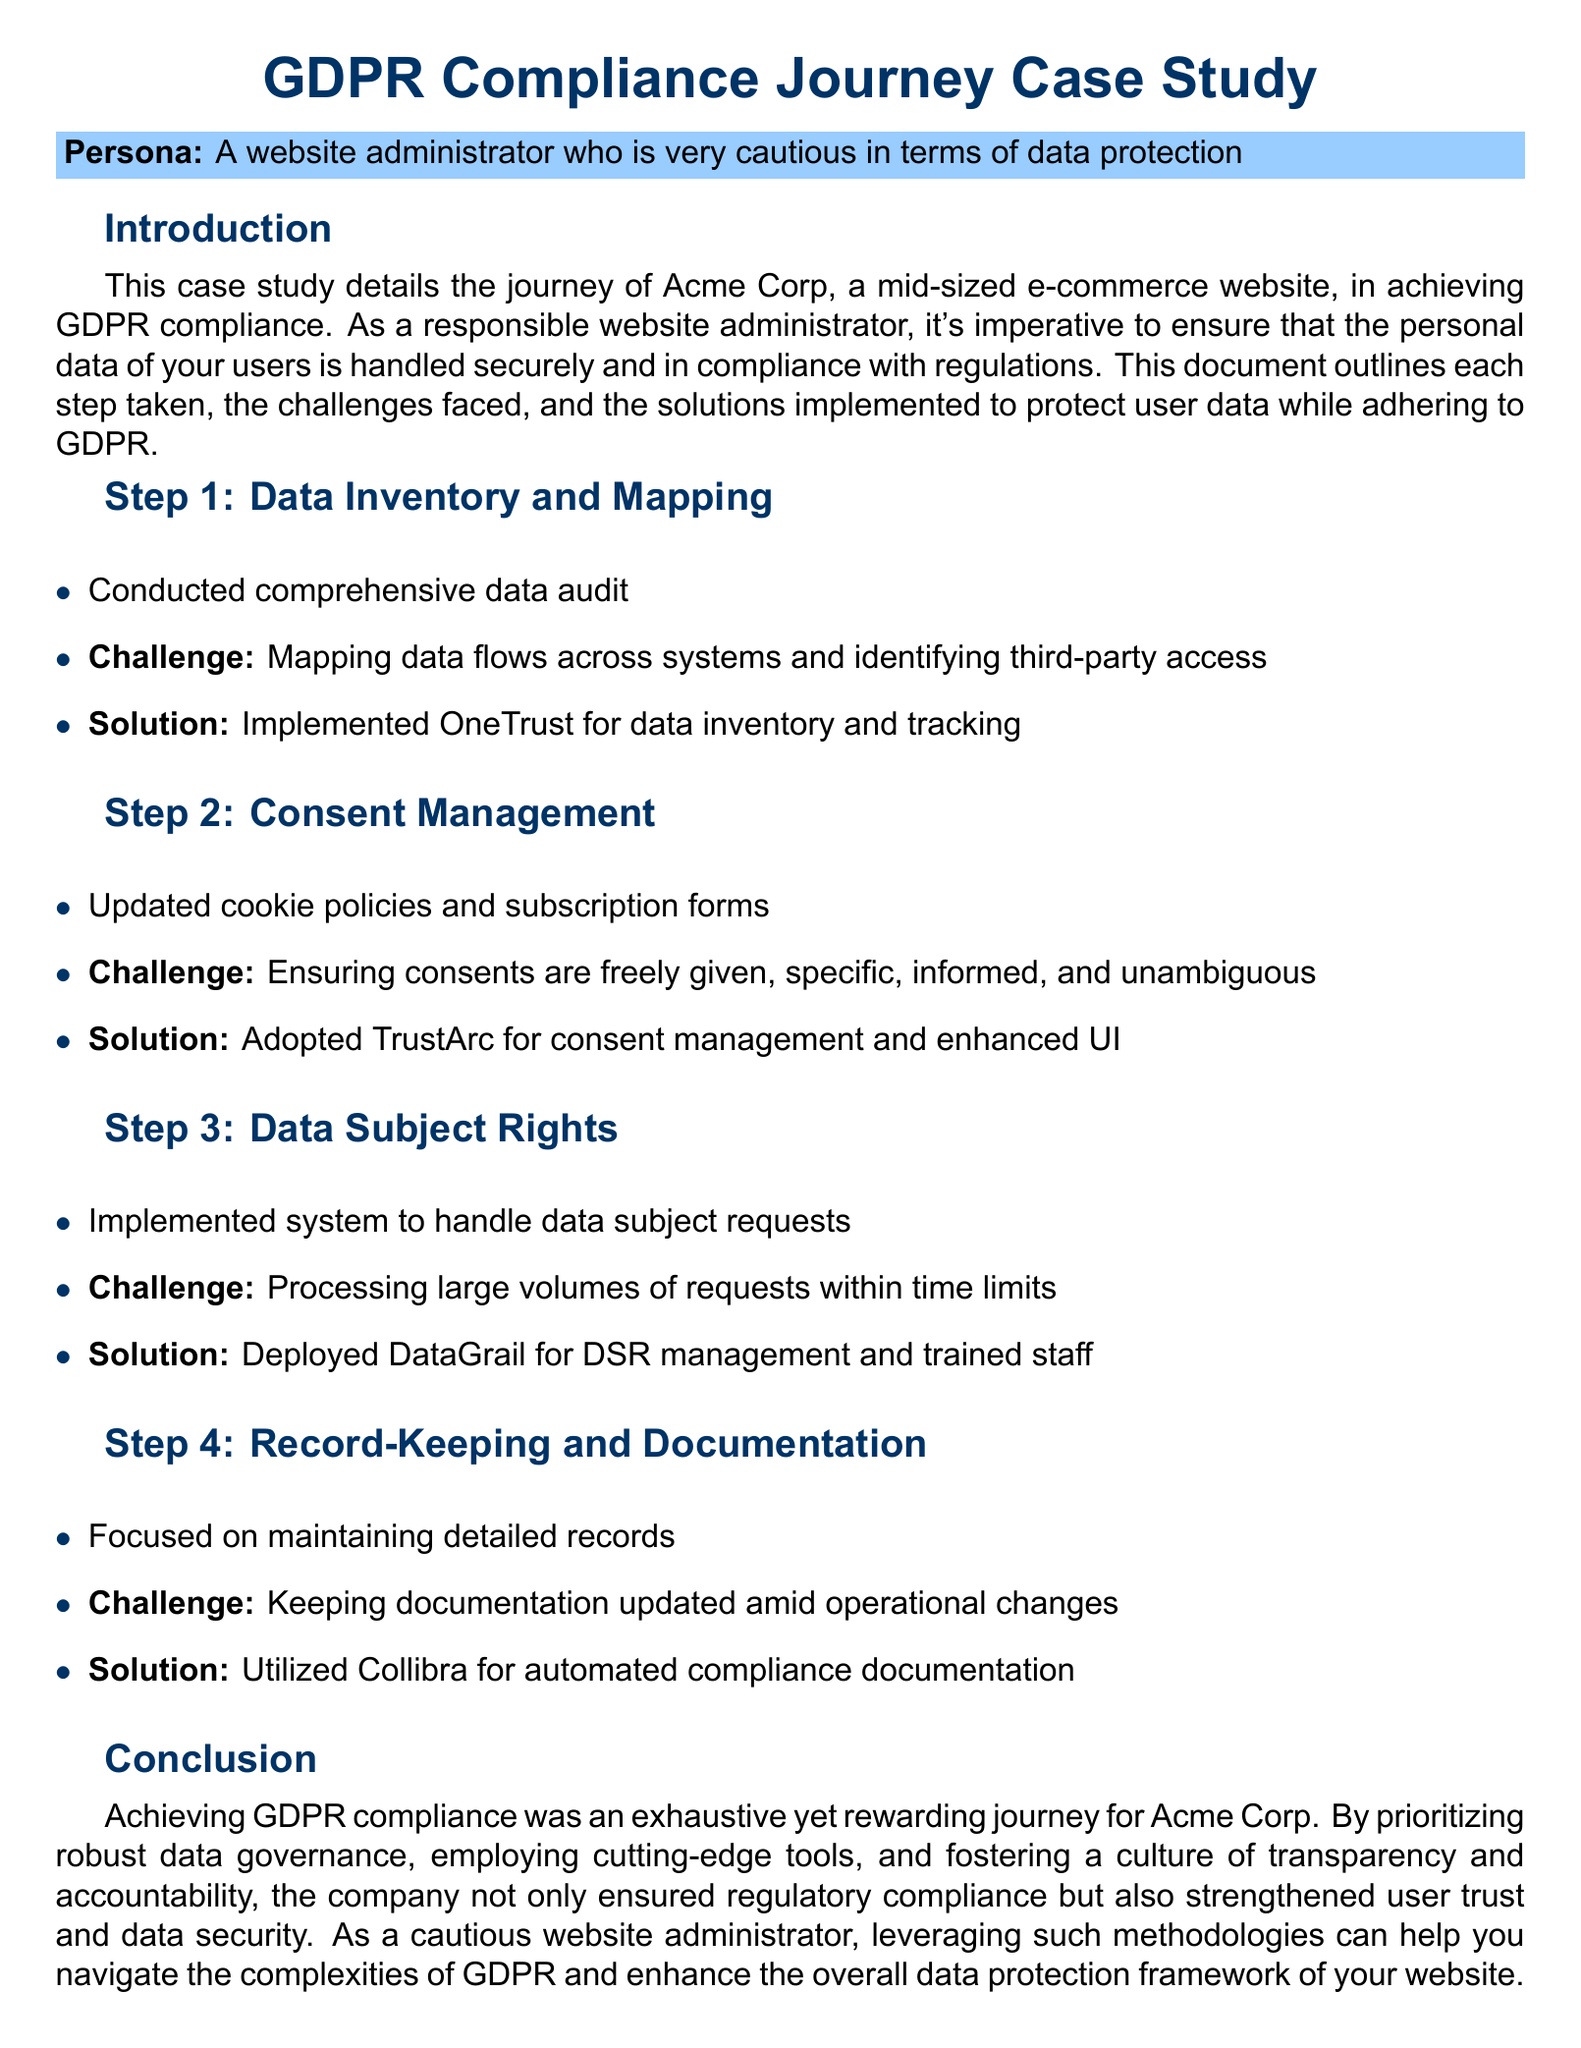What is the name of the company in the case study? The name of the company mentioned in the case study is Acme Corp.
Answer: Acme Corp What is the main focus of the case study? The main focus of the case study is ensuring compliance with GDPR for a mid-sized e-commerce website.
Answer: GDPR compliance What tool was implemented for data inventory and tracking? The tool implemented for data inventory and tracking is OneTrust.
Answer: OneTrust What was a major challenge in Step 2: Consent Management? A major challenge in Step 2 was ensuring consents are freely given, specific, informed, and unambiguous.
Answer: Ensuring consents are freely given How did Acme Corp manage data subject requests? Acme Corp managed data subject requests by deploying DataGrail for DSR management.
Answer: DataGrail What solution was used for automated compliance documentation? The solution used for automated compliance documentation is Collibra.
Answer: Collibra What is a key outcome of Acme Corp's GDPR compliance journey? A key outcome of Acme Corp's GDPR compliance journey is the strengthening of user trust and data security.
Answer: Strengthened user trust What type of training was provided to the staff? The training provided to the staff was related to processing data subject requests.
Answer: DSR management training What color scheme is used for the document's headings? The color scheme used for the document's headings includes a main color of dark blue.
Answer: Dark blue 